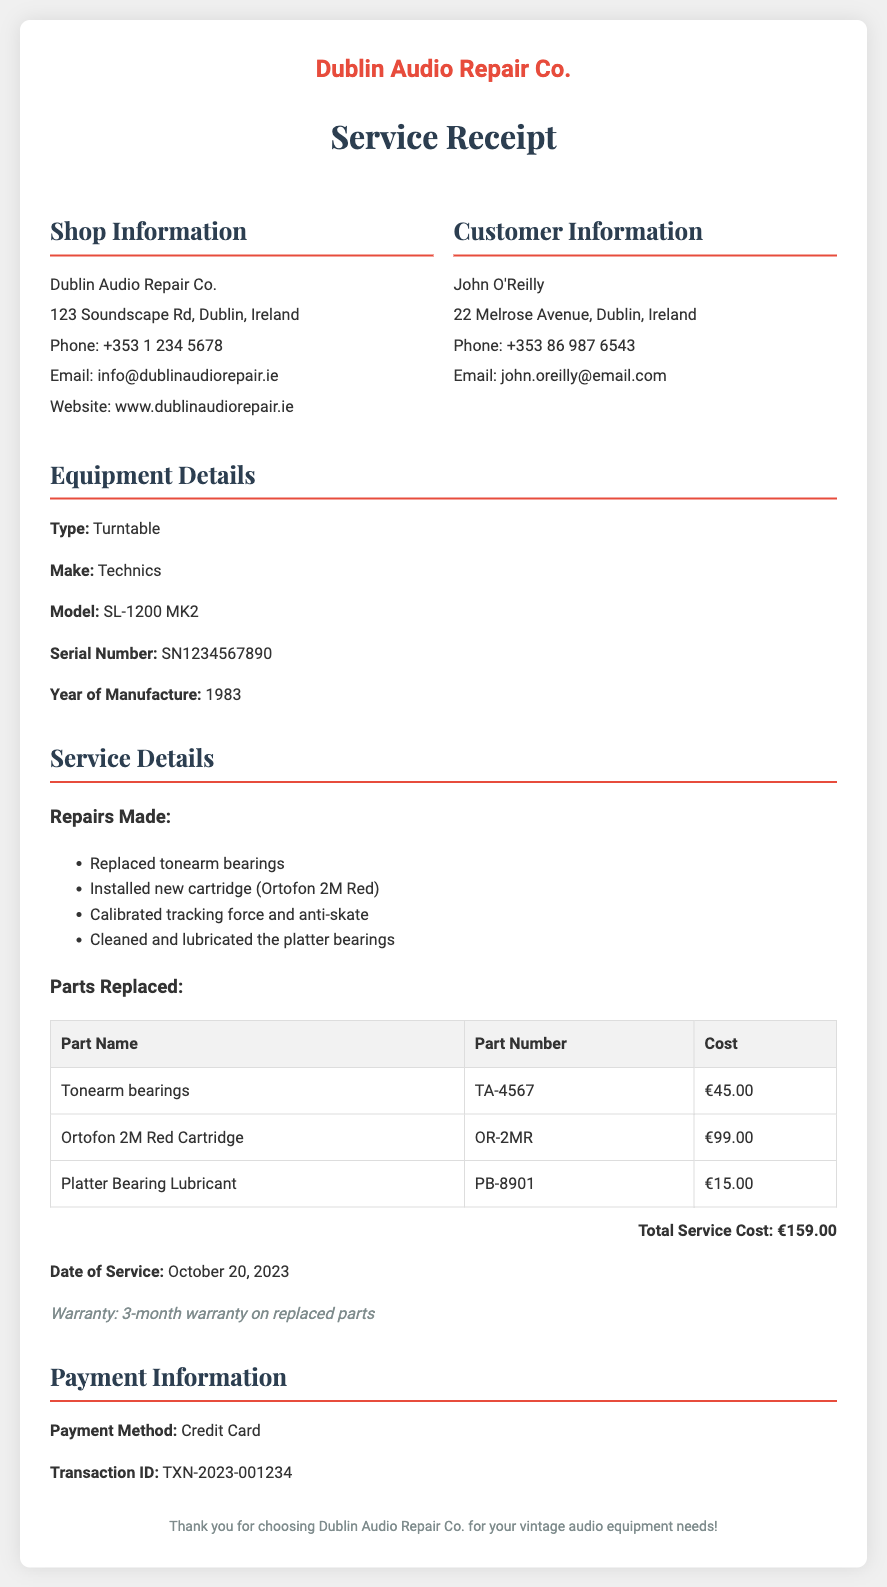What is the name of the repair shop? The repair shop is named "Dublin Audio Repair Co." as stated in the document.
Answer: Dublin Audio Repair Co Who is the customer? The customer's name is provided in the customer information section of the document.
Answer: John O'Reilly What is the total service cost? The total service cost is explicitly mentioned in the service details section of the document.
Answer: €159.00 What parts were replaced? The document lists specific parts replaced during the service in the parts table.
Answer: Tonearm bearings, Ortofon 2M Red Cartridge, Platter Bearing Lubricant When was the service completed? The date when the service was completed is clearly indicated in the service details section.
Answer: October 20, 2023 What type of payment method was used? The payment method is specified under the payment information section in the document.
Answer: Credit Card What warranty is provided on replaced parts? The warranty information is stated clearly in the service details section of the document.
Answer: 3-month warranty What was the make and model of the turntable? The make and model are specified in the equipment details section of the document.
Answer: Technics SL-1200 MK2 